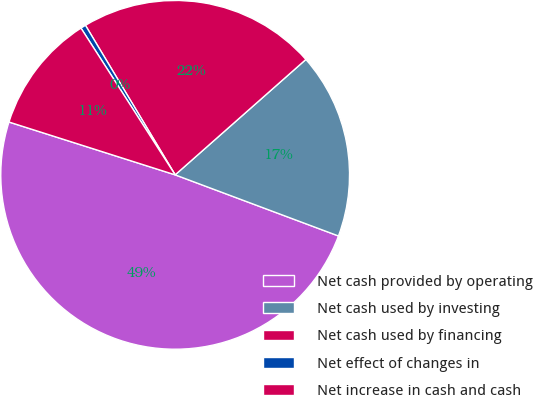<chart> <loc_0><loc_0><loc_500><loc_500><pie_chart><fcel>Net cash provided by operating<fcel>Net cash used by investing<fcel>Net cash used by financing<fcel>Net effect of changes in<fcel>Net increase in cash and cash<nl><fcel>49.2%<fcel>17.21%<fcel>22.09%<fcel>0.48%<fcel>11.02%<nl></chart> 